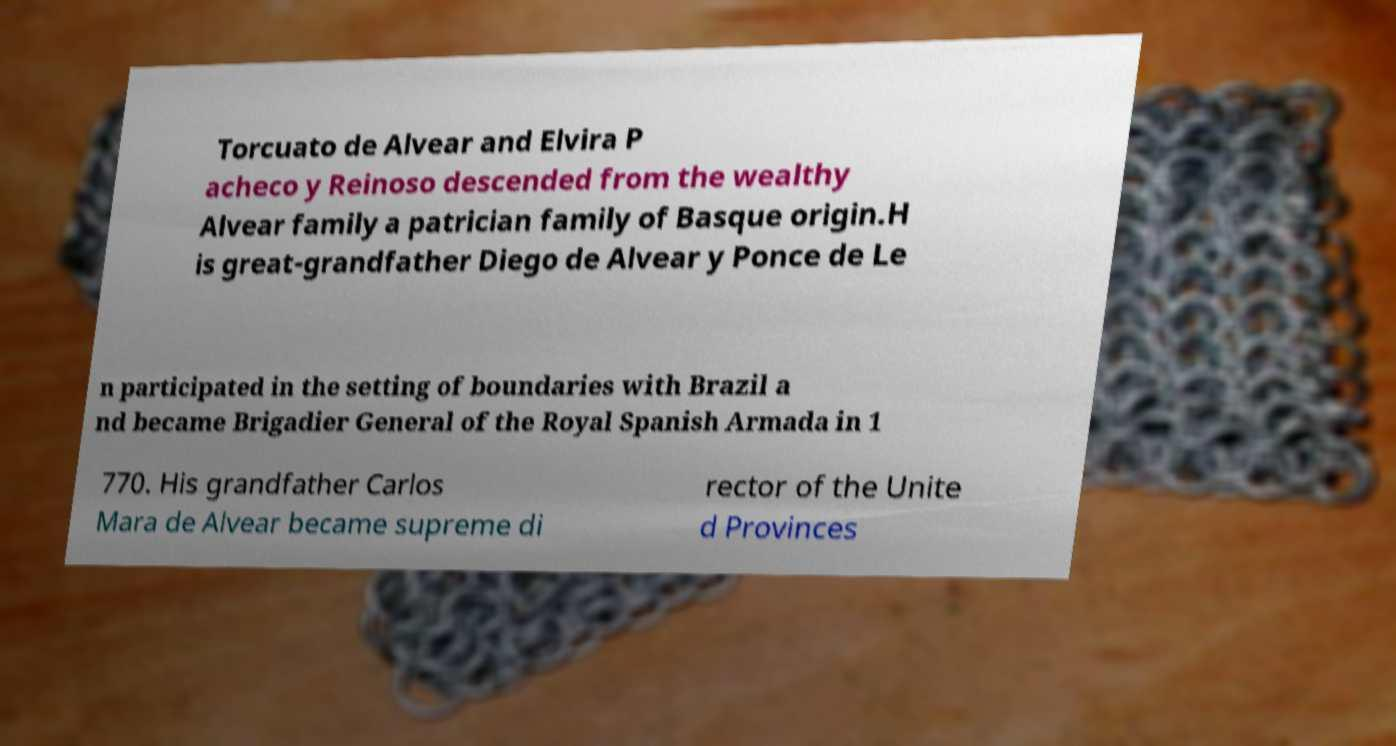Can you accurately transcribe the text from the provided image for me? Torcuato de Alvear and Elvira P acheco y Reinoso descended from the wealthy Alvear family a patrician family of Basque origin.H is great-grandfather Diego de Alvear y Ponce de Le n participated in the setting of boundaries with Brazil a nd became Brigadier General of the Royal Spanish Armada in 1 770. His grandfather Carlos Mara de Alvear became supreme di rector of the Unite d Provinces 